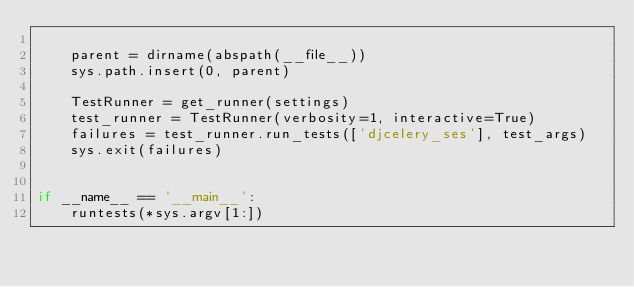<code> <loc_0><loc_0><loc_500><loc_500><_Python_>
    parent = dirname(abspath(__file__))
    sys.path.insert(0, parent)

    TestRunner = get_runner(settings)
    test_runner = TestRunner(verbosity=1, interactive=True)
    failures = test_runner.run_tests(['djcelery_ses'], test_args)
    sys.exit(failures)


if __name__ == '__main__':
    runtests(*sys.argv[1:])
</code> 